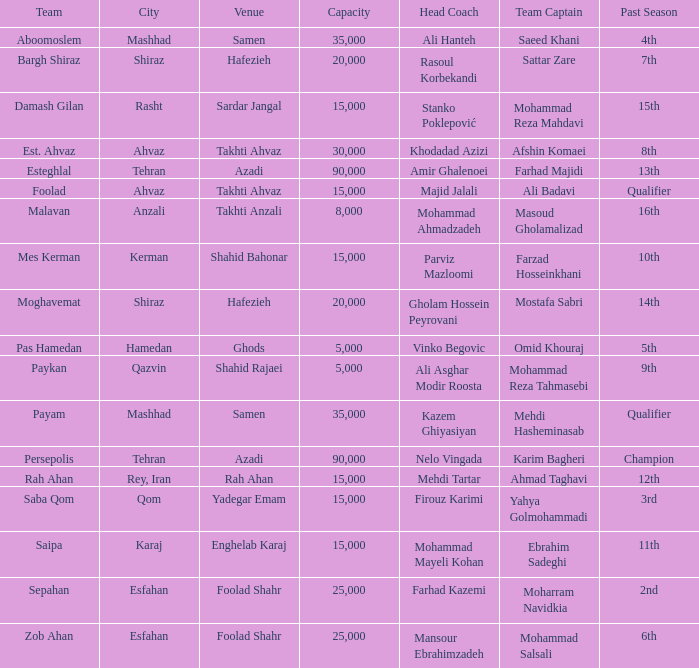What is the capability of the venue of head coach farhad kazemi? 25000.0. 